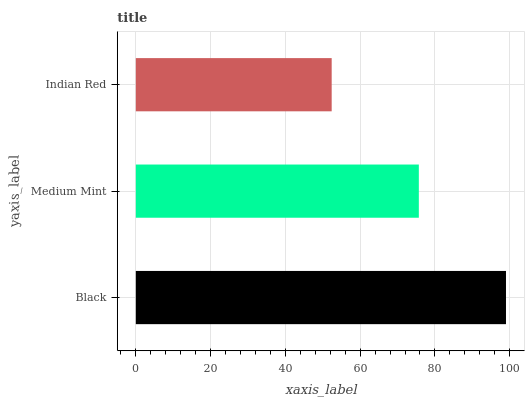Is Indian Red the minimum?
Answer yes or no. Yes. Is Black the maximum?
Answer yes or no. Yes. Is Medium Mint the minimum?
Answer yes or no. No. Is Medium Mint the maximum?
Answer yes or no. No. Is Black greater than Medium Mint?
Answer yes or no. Yes. Is Medium Mint less than Black?
Answer yes or no. Yes. Is Medium Mint greater than Black?
Answer yes or no. No. Is Black less than Medium Mint?
Answer yes or no. No. Is Medium Mint the high median?
Answer yes or no. Yes. Is Medium Mint the low median?
Answer yes or no. Yes. Is Black the high median?
Answer yes or no. No. Is Indian Red the low median?
Answer yes or no. No. 